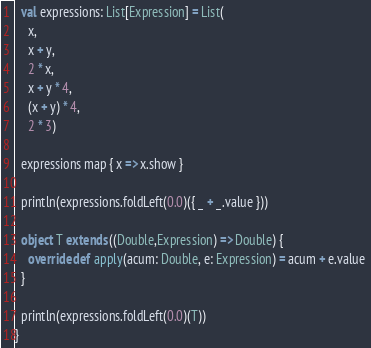Convert code to text. <code><loc_0><loc_0><loc_500><loc_500><_Scala_>
  val expressions: List[Expression] = List(
    x,
    x + y,
    2 * x,
    x + y * 4,
    (x + y) * 4,
    2 * 3)

  expressions map { x => x.show }

  println(expressions.foldLeft(0.0)({ _ + _.value }))

  object T extends ((Double,Expression) => Double) {
    override def apply(acum: Double, e: Expression) = acum + e.value 
  }
  
  println(expressions.foldLeft(0.0)(T))  
}

</code> 